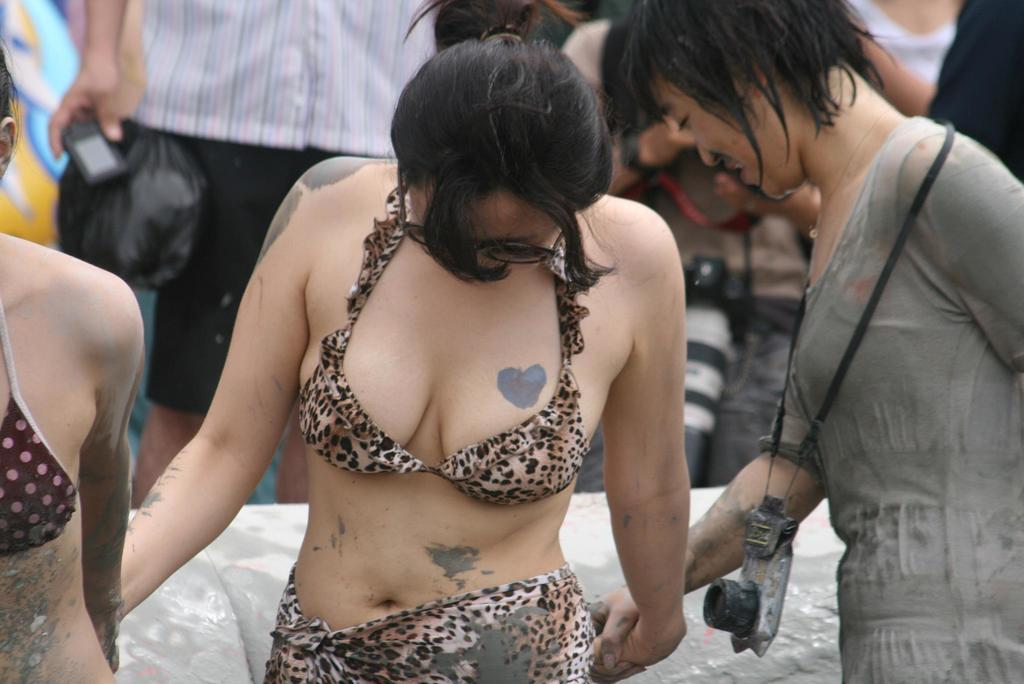Who is in the foreground of the image? There are women in the foreground of the image. Can you describe the people in the background of the image? There are people in the background of the image. What type of list can be seen in the women holding in the image? There is no list present in the image; the women are not holding anything. 